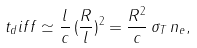<formula> <loc_0><loc_0><loc_500><loc_500>t _ { d } i f f \simeq \frac { l } { c } \, ( \frac { R } { l } ) ^ { 2 } = \frac { R ^ { 2 } } { c } \, \sigma _ { T } \, n _ { e } ,</formula> 